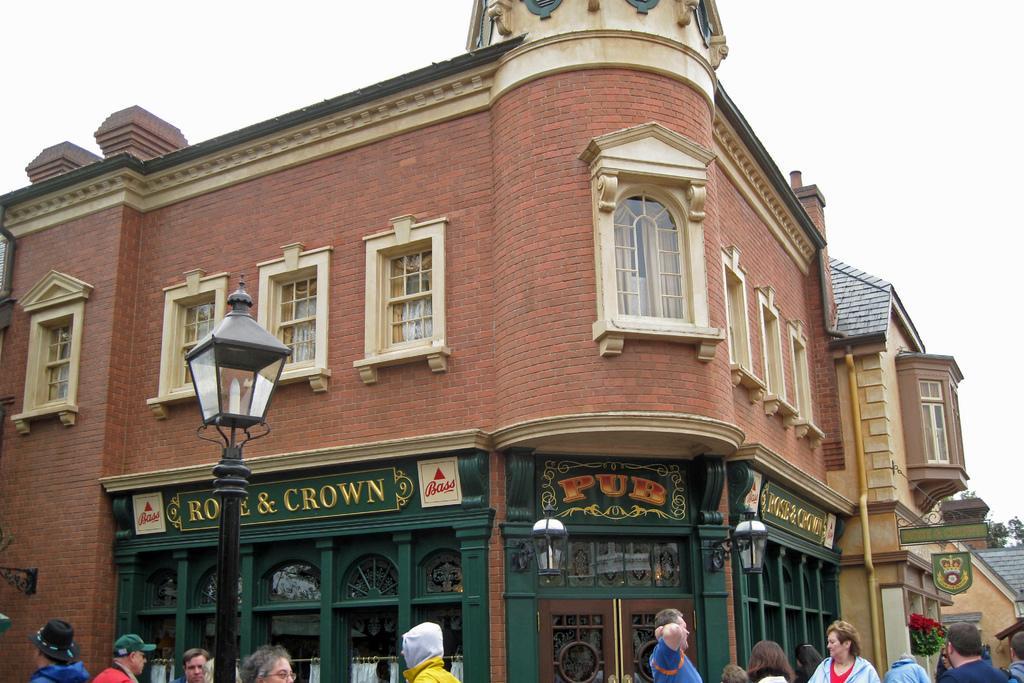In one or two sentences, can you explain what this image depicts? In the image there is a building in the front with many windows and doors and there are many people walking in front of the building and above its sky. 